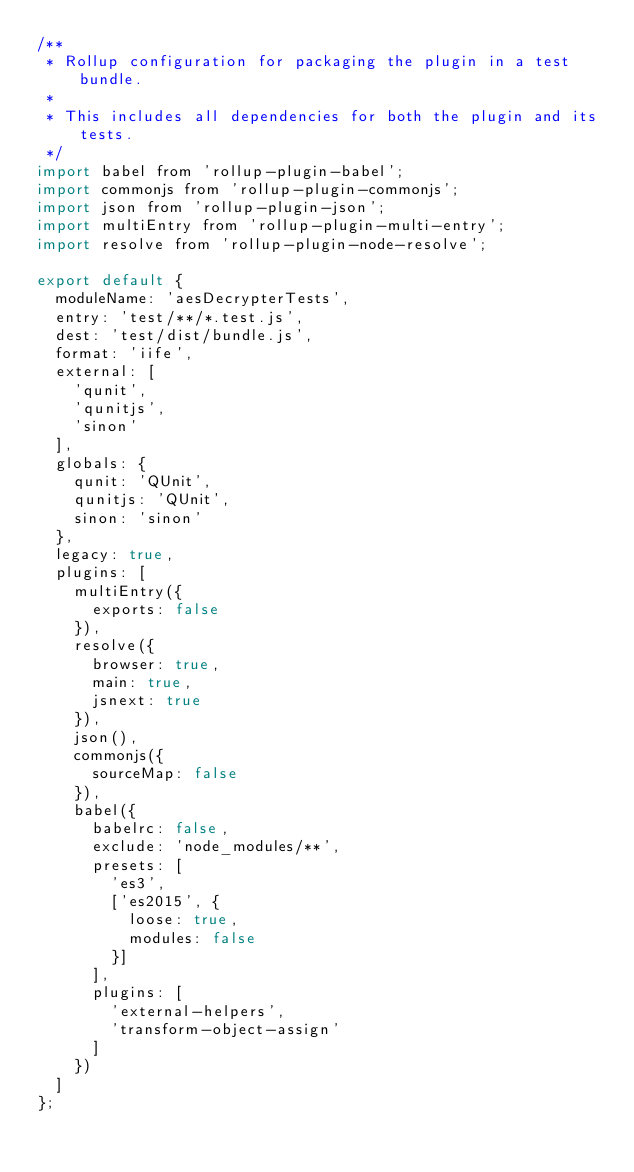<code> <loc_0><loc_0><loc_500><loc_500><_JavaScript_>/**
 * Rollup configuration for packaging the plugin in a test bundle.
 *
 * This includes all dependencies for both the plugin and its tests.
 */
import babel from 'rollup-plugin-babel';
import commonjs from 'rollup-plugin-commonjs';
import json from 'rollup-plugin-json';
import multiEntry from 'rollup-plugin-multi-entry';
import resolve from 'rollup-plugin-node-resolve';

export default {
  moduleName: 'aesDecrypterTests',
  entry: 'test/**/*.test.js',
  dest: 'test/dist/bundle.js',
  format: 'iife',
  external: [
    'qunit',
    'qunitjs',
    'sinon'
  ],
  globals: {
    qunit: 'QUnit',
    qunitjs: 'QUnit',
    sinon: 'sinon'
  },
  legacy: true,
  plugins: [
    multiEntry({
      exports: false
    }),
    resolve({
      browser: true,
      main: true,
      jsnext: true
    }),
    json(),
    commonjs({
      sourceMap: false
    }),
    babel({
      babelrc: false,
      exclude: 'node_modules/**',
      presets: [
        'es3',
        ['es2015', {
          loose: true,
          modules: false
        }]
      ],
      plugins: [
        'external-helpers',
        'transform-object-assign'
      ]
    })
  ]
};
</code> 